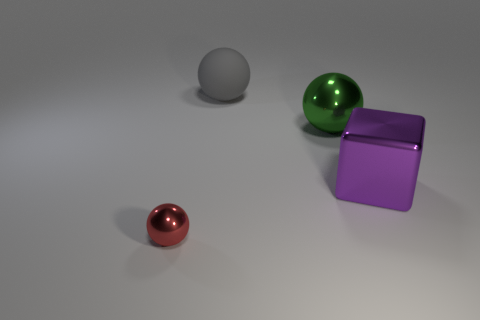Add 4 purple objects. How many objects exist? 8 Subtract all blocks. How many objects are left? 3 Add 4 big blue metallic objects. How many big blue metallic objects exist? 4 Subtract 0 green cylinders. How many objects are left? 4 Subtract all large purple shiny cylinders. Subtract all gray matte spheres. How many objects are left? 3 Add 2 big rubber balls. How many big rubber balls are left? 3 